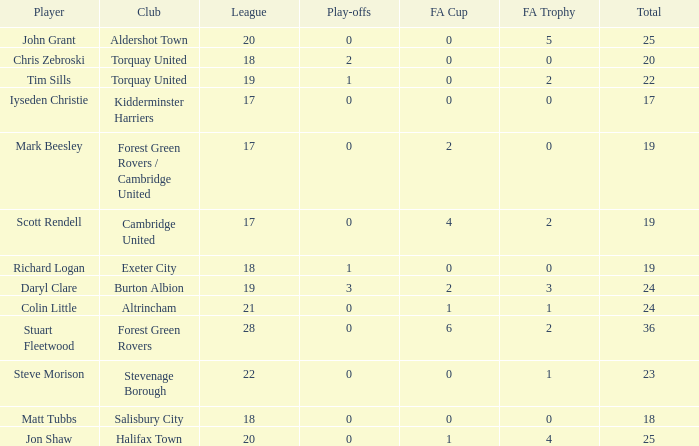What is the mean number of play-offs when the league number was bigger than 18, where the player was John Grant and the total number was bigger than 25? None. 